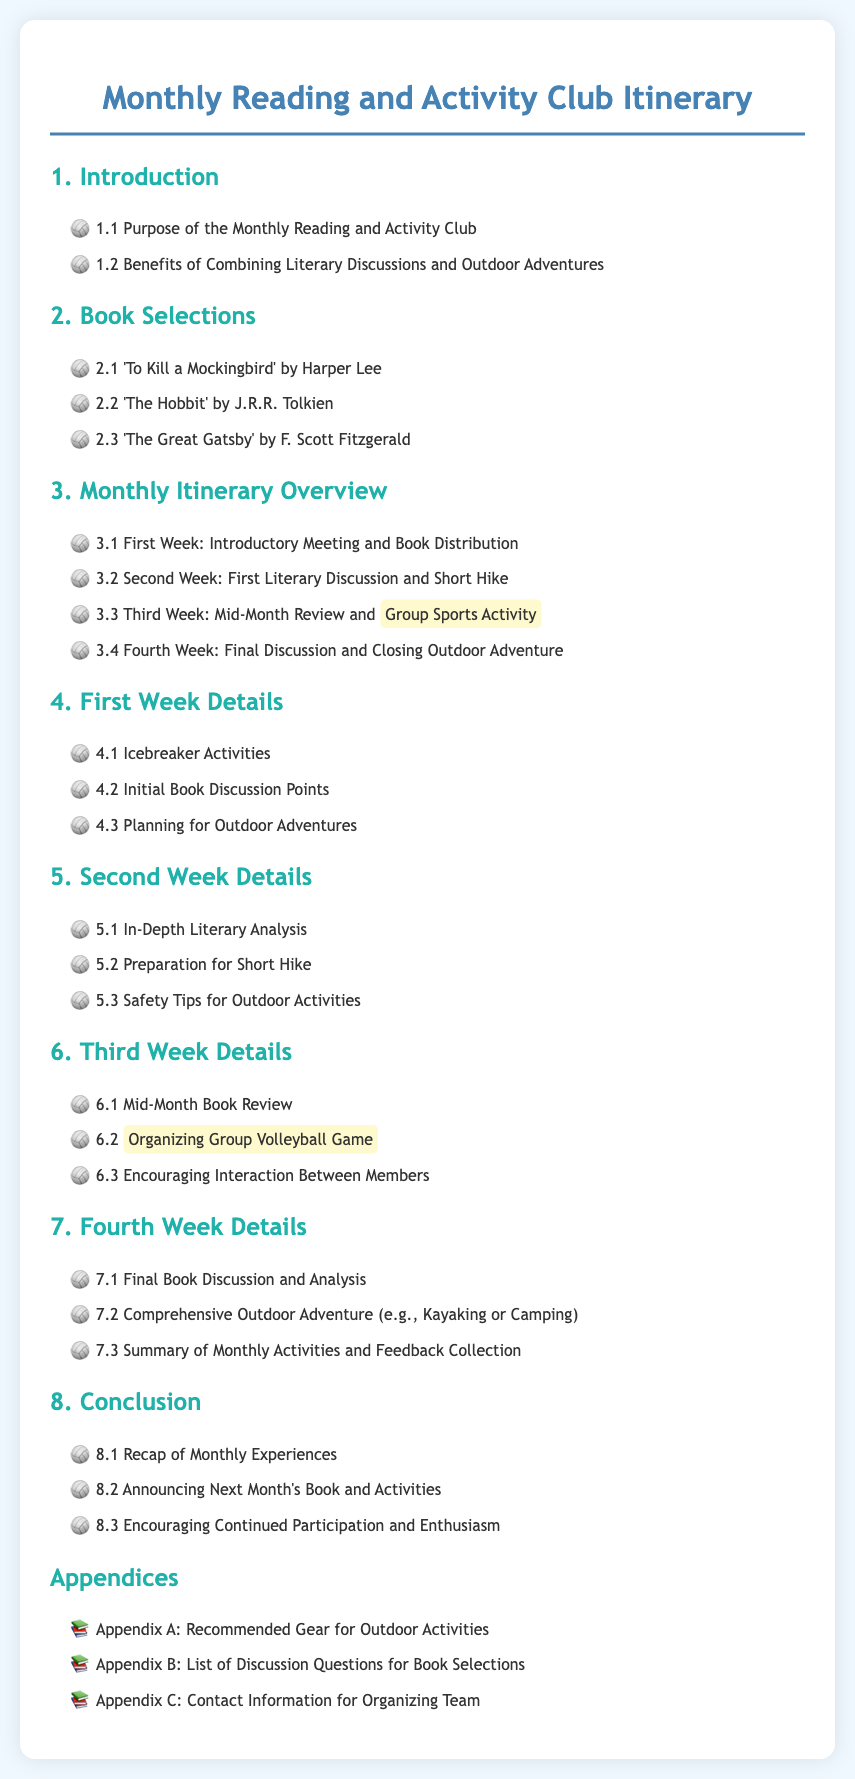What is the purpose of the Monthly Reading and Activity Club? The purpose is stated in section 1.1 of the document.
Answer: Purpose of the Monthly Reading and Activity Club How many books are selected for the club? The number of books selected can be found in section 2 of the document.
Answer: 3 Which book is discussed in the second week? The book discussed is mentioned in section 5.1 of the document.
Answer: 'To Kill a Mockingbird' What activity takes place in the third week? The specific activity is noted in section 6.2 of the document.
Answer: Group Volleyball Game What is included in the appendices? The appendices provide additional resources listed in section 8.
Answer: Recommended Gear for Outdoor Activities What is a key benefit of combining literary discussions and outdoor adventures? The benefits are outlined in section 1.2 of the document.
Answer: Encouraging active participation When does the final discussion occur? The timing of the final discussion is indicated in section 7.1.
Answer: Fourth Week How many appendices are included? The total number of appendices can be counted from the listed items in section 8.
Answer: 3 